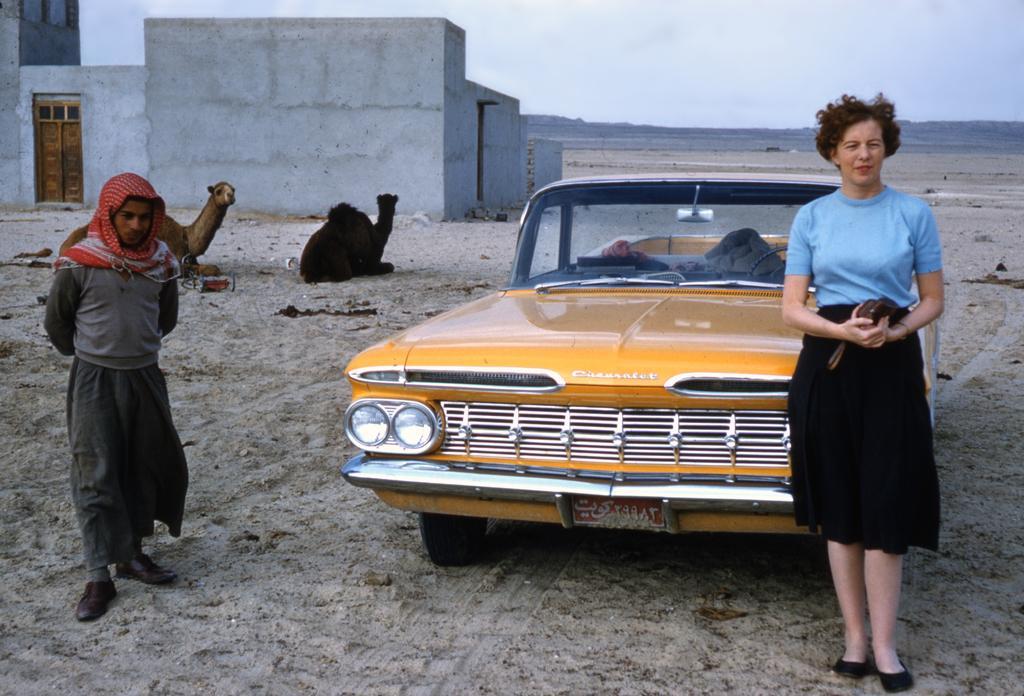Can you describe this image briefly? In the foreground of the image there are two people. There is a car. At the bottom of the image there is sand. In the background of the image there are two camels, house, sky and clouds. 